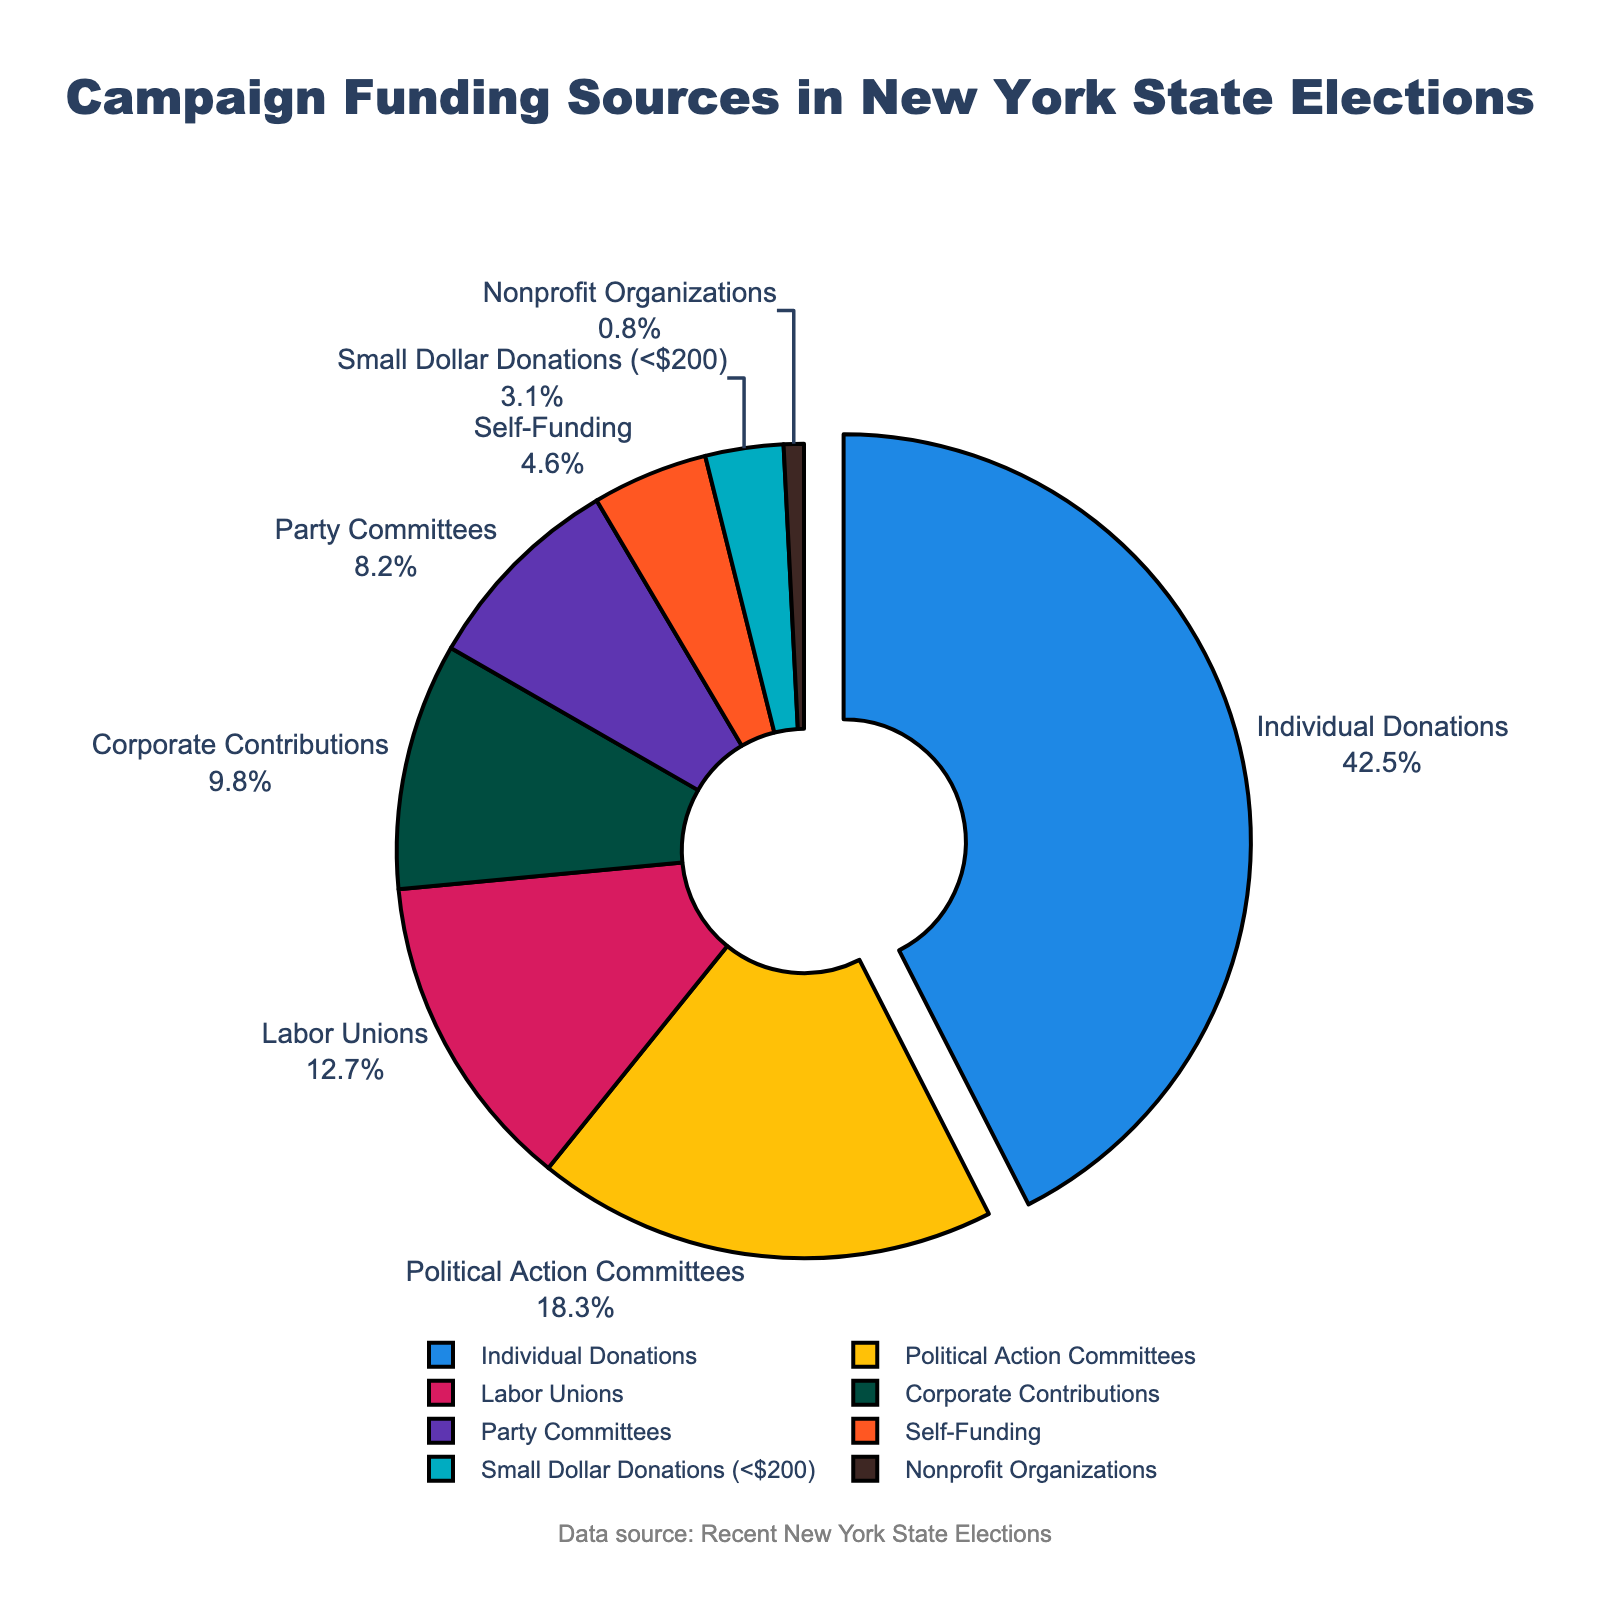what is the highest funding source? Identify the slice that is pulled out and has the highest percentage. "Individual Donations" with 42.5% is the largest.
Answer: Individual Donations how much more funding do political action committees contribute compared to labor unions? Refer to the percent values of Political Action Committees (18.3%) and Labor Unions (12.7%). Subtract 12.7 from 18.3 to find the difference.
Answer: 5.6% which funding sources contribute less than 10% each? Identify slices with percentages under 10%. These are Corporate Contributions (9.8%), Party Committees (8.2%), Self-Funding (4.6%), Small Dollar Donations (3.1%), and Nonprofit Organizations (0.8%).
Answer: Corporate Contributions, Party Committees, Self-Funding, Small Dollar Donations, Nonprofit Organizations what is the combined percentage of corporate contributions and party committees? Add the percentages of Corporate Contributions (9.8%) and Party Committees (8.2%). The combined value is 9.8 + 8.2.
Answer: 18% which source of funding is represented by the blue color? Identify the color coding for each slice and match blue color to its source. The blue color corresponds to Individual Donations.
Answer: Individual Donations what is the total contribution of the three smallest funding sources? Sum the percentages of the three smallest funding sources: Small Dollar Donations (3.1%), Self-Funding (4.6%), and Nonprofit Organizations (0.8%). The total is 3.1 + 4.6 + 0.8.
Answer: 8.5% are individual donations more than double the percentage of any other single funding source? Double the highest percentage other than Individual Donations, which is Political Action Committees (18.3%). The doubled value is 18.3 x 2. Compare this with Individual Donations (42.5%). Since 42.5 < 36.6, Individual Donations are not more than double.
Answer: No by how much does the percentage of individual donations exceed the combined percentage of labor unions and party committees? Add the percentages of Labor Unions (12.7%) and Party Committees (8.2%) to get the combined percentage (20.9%). Subtract this from Individual Donations (42.5%) to find the difference (42.5 - 20.9).
Answer: 21.6% is the percentage of self-funding greater than one-half of corporate contributions? Halve the percentage of Corporate Contributions (9.8%) to get 4.9%. Compare this with Self-Funding (4.6%).
Answer: No 